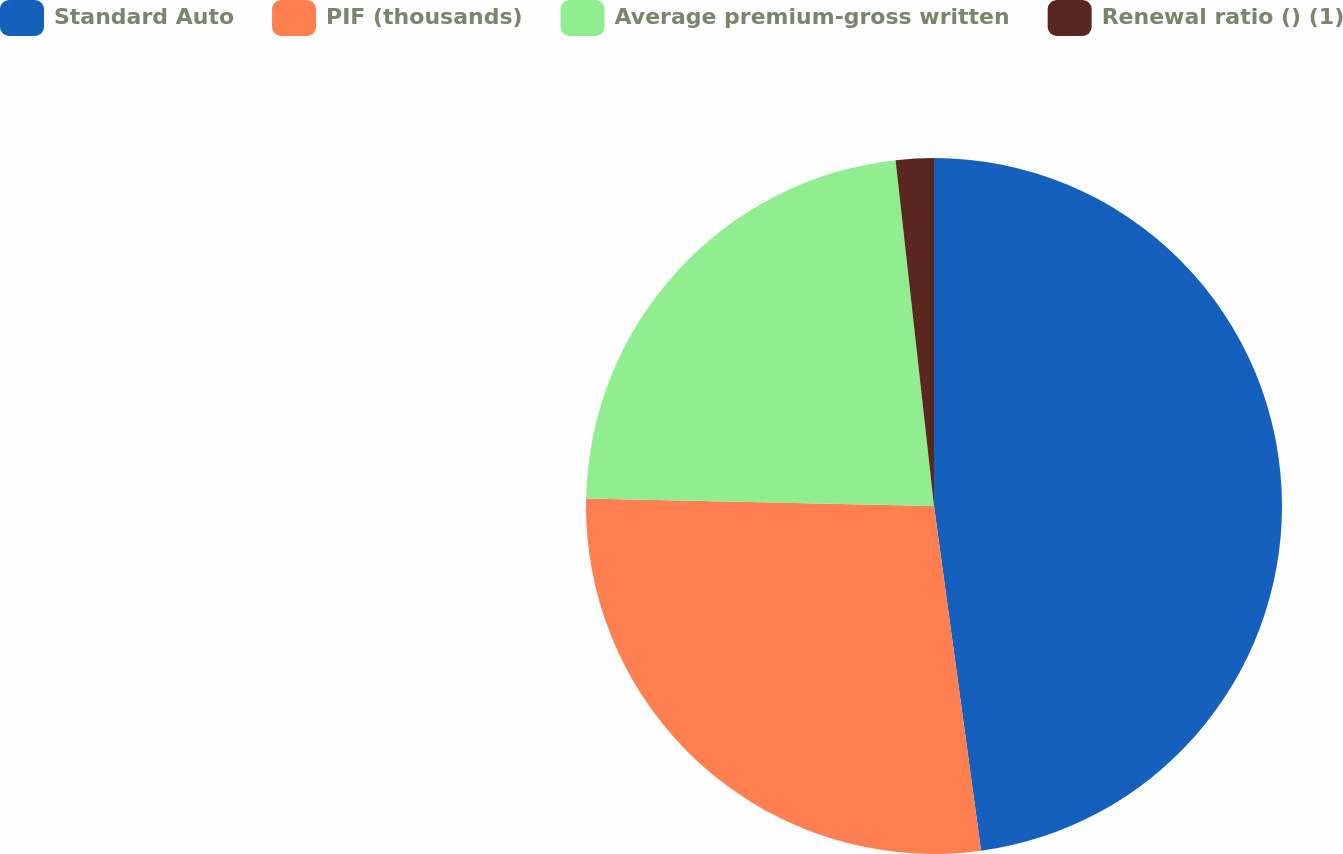Convert chart to OTSL. <chart><loc_0><loc_0><loc_500><loc_500><pie_chart><fcel>Standard Auto<fcel>PIF (thousands)<fcel>Average premium-gross written<fcel>Renewal ratio () (1)<nl><fcel>47.84%<fcel>27.5%<fcel>22.9%<fcel>1.76%<nl></chart> 